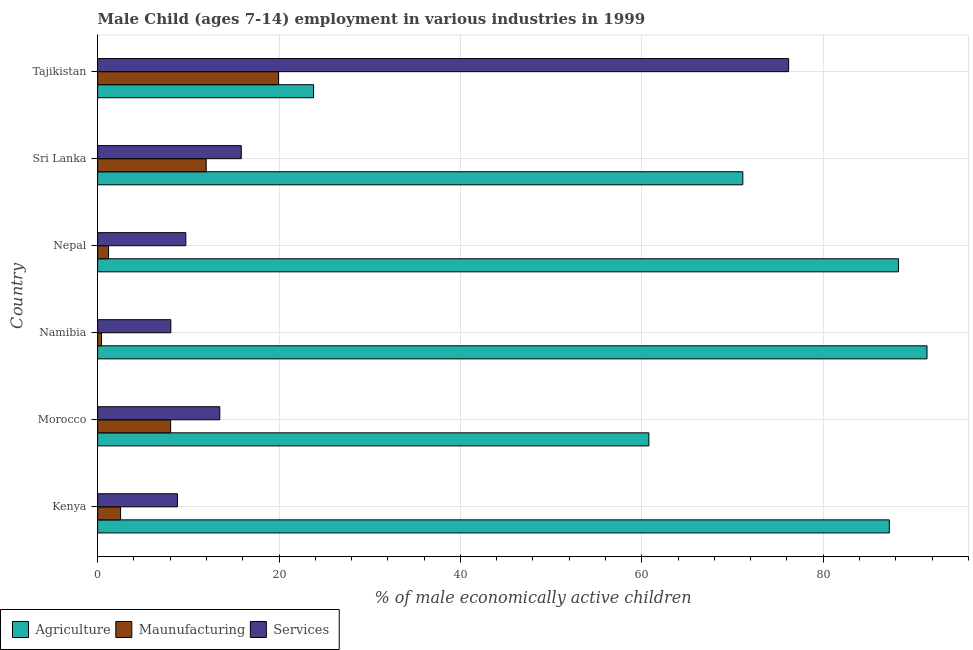Are the number of bars per tick equal to the number of legend labels?
Provide a succinct answer. Yes. Are the number of bars on each tick of the Y-axis equal?
Keep it short and to the point. Yes. What is the label of the 6th group of bars from the top?
Offer a very short reply. Kenya. In how many cases, is the number of bars for a given country not equal to the number of legend labels?
Your answer should be very brief. 0. What is the percentage of economically active children in services in Morocco?
Offer a very short reply. 13.47. Across all countries, what is the maximum percentage of economically active children in manufacturing?
Offer a very short reply. 19.94. Across all countries, what is the minimum percentage of economically active children in manufacturing?
Your answer should be very brief. 0.43. In which country was the percentage of economically active children in services maximum?
Your answer should be very brief. Tajikistan. In which country was the percentage of economically active children in manufacturing minimum?
Your response must be concise. Namibia. What is the total percentage of economically active children in agriculture in the graph?
Your answer should be compact. 422.77. What is the difference between the percentage of economically active children in agriculture in Nepal and that in Tajikistan?
Give a very brief answer. 64.49. What is the difference between the percentage of economically active children in services in Namibia and the percentage of economically active children in agriculture in Nepal?
Make the answer very short. -80.23. What is the average percentage of economically active children in agriculture per country?
Make the answer very short. 70.46. What is the difference between the percentage of economically active children in services and percentage of economically active children in agriculture in Namibia?
Provide a short and direct response. -83.38. What is the ratio of the percentage of economically active children in agriculture in Morocco to that in Tajikistan?
Give a very brief answer. 2.55. What is the difference between the highest and the second highest percentage of economically active children in services?
Offer a terse response. 60.35. What is the difference between the highest and the lowest percentage of economically active children in agriculture?
Offer a very short reply. 67.64. Is the sum of the percentage of economically active children in manufacturing in Morocco and Sri Lanka greater than the maximum percentage of economically active children in agriculture across all countries?
Ensure brevity in your answer.  No. What does the 1st bar from the top in Nepal represents?
Provide a short and direct response. Services. What does the 2nd bar from the bottom in Morocco represents?
Make the answer very short. Maunufacturing. How many countries are there in the graph?
Your answer should be very brief. 6. What is the difference between two consecutive major ticks on the X-axis?
Your answer should be very brief. 20. Are the values on the major ticks of X-axis written in scientific E-notation?
Give a very brief answer. No. Does the graph contain any zero values?
Give a very brief answer. No. How are the legend labels stacked?
Ensure brevity in your answer.  Horizontal. What is the title of the graph?
Your answer should be compact. Male Child (ages 7-14) employment in various industries in 1999. What is the label or title of the X-axis?
Your answer should be compact. % of male economically active children. What is the label or title of the Y-axis?
Your response must be concise. Country. What is the % of male economically active children of Agriculture in Kenya?
Give a very brief answer. 87.29. What is the % of male economically active children of Maunufacturing in Kenya?
Give a very brief answer. 2.53. What is the % of male economically active children in Services in Kenya?
Your answer should be very brief. 8.8. What is the % of male economically active children in Agriculture in Morocco?
Offer a very short reply. 60.78. What is the % of male economically active children in Maunufacturing in Morocco?
Your response must be concise. 8.05. What is the % of male economically active children in Services in Morocco?
Provide a succinct answer. 13.47. What is the % of male economically active children in Agriculture in Namibia?
Your response must be concise. 91.45. What is the % of male economically active children of Maunufacturing in Namibia?
Provide a short and direct response. 0.43. What is the % of male economically active children of Services in Namibia?
Your answer should be compact. 8.07. What is the % of male economically active children in Agriculture in Nepal?
Give a very brief answer. 88.3. What is the % of male economically active children of Maunufacturing in Nepal?
Give a very brief answer. 1.2. What is the % of male economically active children of Services in Nepal?
Offer a very short reply. 9.72. What is the % of male economically active children in Agriculture in Sri Lanka?
Give a very brief answer. 71.14. What is the % of male economically active children in Maunufacturing in Sri Lanka?
Keep it short and to the point. 11.97. What is the % of male economically active children in Services in Sri Lanka?
Ensure brevity in your answer.  15.84. What is the % of male economically active children of Agriculture in Tajikistan?
Ensure brevity in your answer.  23.81. What is the % of male economically active children in Maunufacturing in Tajikistan?
Keep it short and to the point. 19.94. What is the % of male economically active children of Services in Tajikistan?
Your response must be concise. 76.19. Across all countries, what is the maximum % of male economically active children of Agriculture?
Your response must be concise. 91.45. Across all countries, what is the maximum % of male economically active children in Maunufacturing?
Provide a succinct answer. 19.94. Across all countries, what is the maximum % of male economically active children of Services?
Ensure brevity in your answer.  76.19. Across all countries, what is the minimum % of male economically active children in Agriculture?
Give a very brief answer. 23.81. Across all countries, what is the minimum % of male economically active children of Maunufacturing?
Provide a succinct answer. 0.43. Across all countries, what is the minimum % of male economically active children of Services?
Give a very brief answer. 8.07. What is the total % of male economically active children of Agriculture in the graph?
Your response must be concise. 422.77. What is the total % of male economically active children in Maunufacturing in the graph?
Ensure brevity in your answer.  44.13. What is the total % of male economically active children in Services in the graph?
Provide a succinct answer. 132.09. What is the difference between the % of male economically active children of Agriculture in Kenya and that in Morocco?
Ensure brevity in your answer.  26.51. What is the difference between the % of male economically active children in Maunufacturing in Kenya and that in Morocco?
Your answer should be compact. -5.52. What is the difference between the % of male economically active children in Services in Kenya and that in Morocco?
Give a very brief answer. -4.67. What is the difference between the % of male economically active children of Agriculture in Kenya and that in Namibia?
Your answer should be very brief. -4.16. What is the difference between the % of male economically active children of Maunufacturing in Kenya and that in Namibia?
Provide a short and direct response. 2.1. What is the difference between the % of male economically active children of Services in Kenya and that in Namibia?
Keep it short and to the point. 0.73. What is the difference between the % of male economically active children in Agriculture in Kenya and that in Nepal?
Ensure brevity in your answer.  -1.01. What is the difference between the % of male economically active children of Maunufacturing in Kenya and that in Nepal?
Give a very brief answer. 1.33. What is the difference between the % of male economically active children of Services in Kenya and that in Nepal?
Ensure brevity in your answer.  -0.92. What is the difference between the % of male economically active children in Agriculture in Kenya and that in Sri Lanka?
Your response must be concise. 16.15. What is the difference between the % of male economically active children of Maunufacturing in Kenya and that in Sri Lanka?
Give a very brief answer. -9.44. What is the difference between the % of male economically active children of Services in Kenya and that in Sri Lanka?
Your answer should be compact. -7.04. What is the difference between the % of male economically active children in Agriculture in Kenya and that in Tajikistan?
Offer a terse response. 63.48. What is the difference between the % of male economically active children of Maunufacturing in Kenya and that in Tajikistan?
Ensure brevity in your answer.  -17.41. What is the difference between the % of male economically active children in Services in Kenya and that in Tajikistan?
Give a very brief answer. -67.39. What is the difference between the % of male economically active children of Agriculture in Morocco and that in Namibia?
Keep it short and to the point. -30.67. What is the difference between the % of male economically active children of Maunufacturing in Morocco and that in Namibia?
Make the answer very short. 7.62. What is the difference between the % of male economically active children of Agriculture in Morocco and that in Nepal?
Offer a very short reply. -27.52. What is the difference between the % of male economically active children in Maunufacturing in Morocco and that in Nepal?
Keep it short and to the point. 6.85. What is the difference between the % of male economically active children in Services in Morocco and that in Nepal?
Your answer should be very brief. 3.75. What is the difference between the % of male economically active children in Agriculture in Morocco and that in Sri Lanka?
Your answer should be very brief. -10.36. What is the difference between the % of male economically active children of Maunufacturing in Morocco and that in Sri Lanka?
Give a very brief answer. -3.92. What is the difference between the % of male economically active children of Services in Morocco and that in Sri Lanka?
Give a very brief answer. -2.37. What is the difference between the % of male economically active children of Agriculture in Morocco and that in Tajikistan?
Your response must be concise. 36.97. What is the difference between the % of male economically active children of Maunufacturing in Morocco and that in Tajikistan?
Give a very brief answer. -11.89. What is the difference between the % of male economically active children in Services in Morocco and that in Tajikistan?
Your answer should be compact. -62.72. What is the difference between the % of male economically active children of Agriculture in Namibia and that in Nepal?
Offer a very short reply. 3.15. What is the difference between the % of male economically active children in Maunufacturing in Namibia and that in Nepal?
Your response must be concise. -0.77. What is the difference between the % of male economically active children of Services in Namibia and that in Nepal?
Your answer should be compact. -1.65. What is the difference between the % of male economically active children of Agriculture in Namibia and that in Sri Lanka?
Offer a terse response. 20.31. What is the difference between the % of male economically active children of Maunufacturing in Namibia and that in Sri Lanka?
Make the answer very short. -11.54. What is the difference between the % of male economically active children of Services in Namibia and that in Sri Lanka?
Make the answer very short. -7.77. What is the difference between the % of male economically active children in Agriculture in Namibia and that in Tajikistan?
Your answer should be compact. 67.64. What is the difference between the % of male economically active children in Maunufacturing in Namibia and that in Tajikistan?
Ensure brevity in your answer.  -19.51. What is the difference between the % of male economically active children in Services in Namibia and that in Tajikistan?
Offer a very short reply. -68.12. What is the difference between the % of male economically active children in Agriculture in Nepal and that in Sri Lanka?
Your answer should be very brief. 17.16. What is the difference between the % of male economically active children of Maunufacturing in Nepal and that in Sri Lanka?
Give a very brief answer. -10.77. What is the difference between the % of male economically active children in Services in Nepal and that in Sri Lanka?
Give a very brief answer. -6.12. What is the difference between the % of male economically active children in Agriculture in Nepal and that in Tajikistan?
Give a very brief answer. 64.49. What is the difference between the % of male economically active children in Maunufacturing in Nepal and that in Tajikistan?
Your answer should be very brief. -18.74. What is the difference between the % of male economically active children of Services in Nepal and that in Tajikistan?
Give a very brief answer. -66.47. What is the difference between the % of male economically active children of Agriculture in Sri Lanka and that in Tajikistan?
Your response must be concise. 47.33. What is the difference between the % of male economically active children of Maunufacturing in Sri Lanka and that in Tajikistan?
Provide a succinct answer. -7.97. What is the difference between the % of male economically active children in Services in Sri Lanka and that in Tajikistan?
Your response must be concise. -60.35. What is the difference between the % of male economically active children in Agriculture in Kenya and the % of male economically active children in Maunufacturing in Morocco?
Provide a succinct answer. 79.24. What is the difference between the % of male economically active children of Agriculture in Kenya and the % of male economically active children of Services in Morocco?
Provide a short and direct response. 73.82. What is the difference between the % of male economically active children of Maunufacturing in Kenya and the % of male economically active children of Services in Morocco?
Offer a terse response. -10.94. What is the difference between the % of male economically active children in Agriculture in Kenya and the % of male economically active children in Maunufacturing in Namibia?
Offer a terse response. 86.86. What is the difference between the % of male economically active children in Agriculture in Kenya and the % of male economically active children in Services in Namibia?
Your answer should be very brief. 79.22. What is the difference between the % of male economically active children in Maunufacturing in Kenya and the % of male economically active children in Services in Namibia?
Offer a very short reply. -5.54. What is the difference between the % of male economically active children in Agriculture in Kenya and the % of male economically active children in Maunufacturing in Nepal?
Offer a very short reply. 86.09. What is the difference between the % of male economically active children in Agriculture in Kenya and the % of male economically active children in Services in Nepal?
Ensure brevity in your answer.  77.57. What is the difference between the % of male economically active children of Maunufacturing in Kenya and the % of male economically active children of Services in Nepal?
Keep it short and to the point. -7.19. What is the difference between the % of male economically active children of Agriculture in Kenya and the % of male economically active children of Maunufacturing in Sri Lanka?
Your answer should be compact. 75.32. What is the difference between the % of male economically active children in Agriculture in Kenya and the % of male economically active children in Services in Sri Lanka?
Give a very brief answer. 71.45. What is the difference between the % of male economically active children in Maunufacturing in Kenya and the % of male economically active children in Services in Sri Lanka?
Provide a succinct answer. -13.31. What is the difference between the % of male economically active children in Agriculture in Kenya and the % of male economically active children in Maunufacturing in Tajikistan?
Provide a succinct answer. 67.35. What is the difference between the % of male economically active children of Agriculture in Kenya and the % of male economically active children of Services in Tajikistan?
Ensure brevity in your answer.  11.1. What is the difference between the % of male economically active children in Maunufacturing in Kenya and the % of male economically active children in Services in Tajikistan?
Ensure brevity in your answer.  -73.66. What is the difference between the % of male economically active children of Agriculture in Morocco and the % of male economically active children of Maunufacturing in Namibia?
Offer a very short reply. 60.35. What is the difference between the % of male economically active children of Agriculture in Morocco and the % of male economically active children of Services in Namibia?
Make the answer very short. 52.71. What is the difference between the % of male economically active children of Maunufacturing in Morocco and the % of male economically active children of Services in Namibia?
Provide a succinct answer. -0.02. What is the difference between the % of male economically active children of Agriculture in Morocco and the % of male economically active children of Maunufacturing in Nepal?
Keep it short and to the point. 59.58. What is the difference between the % of male economically active children of Agriculture in Morocco and the % of male economically active children of Services in Nepal?
Keep it short and to the point. 51.06. What is the difference between the % of male economically active children in Maunufacturing in Morocco and the % of male economically active children in Services in Nepal?
Give a very brief answer. -1.67. What is the difference between the % of male economically active children in Agriculture in Morocco and the % of male economically active children in Maunufacturing in Sri Lanka?
Offer a very short reply. 48.81. What is the difference between the % of male economically active children of Agriculture in Morocco and the % of male economically active children of Services in Sri Lanka?
Provide a succinct answer. 44.94. What is the difference between the % of male economically active children of Maunufacturing in Morocco and the % of male economically active children of Services in Sri Lanka?
Offer a very short reply. -7.79. What is the difference between the % of male economically active children of Agriculture in Morocco and the % of male economically active children of Maunufacturing in Tajikistan?
Make the answer very short. 40.84. What is the difference between the % of male economically active children in Agriculture in Morocco and the % of male economically active children in Services in Tajikistan?
Provide a succinct answer. -15.41. What is the difference between the % of male economically active children of Maunufacturing in Morocco and the % of male economically active children of Services in Tajikistan?
Offer a terse response. -68.14. What is the difference between the % of male economically active children of Agriculture in Namibia and the % of male economically active children of Maunufacturing in Nepal?
Your answer should be compact. 90.25. What is the difference between the % of male economically active children of Agriculture in Namibia and the % of male economically active children of Services in Nepal?
Keep it short and to the point. 81.73. What is the difference between the % of male economically active children of Maunufacturing in Namibia and the % of male economically active children of Services in Nepal?
Give a very brief answer. -9.29. What is the difference between the % of male economically active children of Agriculture in Namibia and the % of male economically active children of Maunufacturing in Sri Lanka?
Provide a short and direct response. 79.48. What is the difference between the % of male economically active children in Agriculture in Namibia and the % of male economically active children in Services in Sri Lanka?
Provide a short and direct response. 75.61. What is the difference between the % of male economically active children of Maunufacturing in Namibia and the % of male economically active children of Services in Sri Lanka?
Your answer should be very brief. -15.41. What is the difference between the % of male economically active children of Agriculture in Namibia and the % of male economically active children of Maunufacturing in Tajikistan?
Make the answer very short. 71.51. What is the difference between the % of male economically active children in Agriculture in Namibia and the % of male economically active children in Services in Tajikistan?
Provide a succinct answer. 15.26. What is the difference between the % of male economically active children in Maunufacturing in Namibia and the % of male economically active children in Services in Tajikistan?
Keep it short and to the point. -75.76. What is the difference between the % of male economically active children of Agriculture in Nepal and the % of male economically active children of Maunufacturing in Sri Lanka?
Your response must be concise. 76.33. What is the difference between the % of male economically active children in Agriculture in Nepal and the % of male economically active children in Services in Sri Lanka?
Provide a succinct answer. 72.46. What is the difference between the % of male economically active children in Maunufacturing in Nepal and the % of male economically active children in Services in Sri Lanka?
Provide a succinct answer. -14.64. What is the difference between the % of male economically active children of Agriculture in Nepal and the % of male economically active children of Maunufacturing in Tajikistan?
Offer a very short reply. 68.36. What is the difference between the % of male economically active children in Agriculture in Nepal and the % of male economically active children in Services in Tajikistan?
Provide a short and direct response. 12.11. What is the difference between the % of male economically active children of Maunufacturing in Nepal and the % of male economically active children of Services in Tajikistan?
Keep it short and to the point. -74.99. What is the difference between the % of male economically active children of Agriculture in Sri Lanka and the % of male economically active children of Maunufacturing in Tajikistan?
Your answer should be very brief. 51.2. What is the difference between the % of male economically active children in Agriculture in Sri Lanka and the % of male economically active children in Services in Tajikistan?
Ensure brevity in your answer.  -5.05. What is the difference between the % of male economically active children in Maunufacturing in Sri Lanka and the % of male economically active children in Services in Tajikistan?
Ensure brevity in your answer.  -64.22. What is the average % of male economically active children in Agriculture per country?
Offer a very short reply. 70.46. What is the average % of male economically active children of Maunufacturing per country?
Offer a terse response. 7.35. What is the average % of male economically active children of Services per country?
Your answer should be very brief. 22.02. What is the difference between the % of male economically active children of Agriculture and % of male economically active children of Maunufacturing in Kenya?
Your answer should be very brief. 84.76. What is the difference between the % of male economically active children of Agriculture and % of male economically active children of Services in Kenya?
Give a very brief answer. 78.49. What is the difference between the % of male economically active children of Maunufacturing and % of male economically active children of Services in Kenya?
Your answer should be very brief. -6.27. What is the difference between the % of male economically active children in Agriculture and % of male economically active children in Maunufacturing in Morocco?
Make the answer very short. 52.73. What is the difference between the % of male economically active children in Agriculture and % of male economically active children in Services in Morocco?
Your answer should be compact. 47.31. What is the difference between the % of male economically active children in Maunufacturing and % of male economically active children in Services in Morocco?
Make the answer very short. -5.42. What is the difference between the % of male economically active children of Agriculture and % of male economically active children of Maunufacturing in Namibia?
Ensure brevity in your answer.  91.02. What is the difference between the % of male economically active children of Agriculture and % of male economically active children of Services in Namibia?
Offer a very short reply. 83.38. What is the difference between the % of male economically active children in Maunufacturing and % of male economically active children in Services in Namibia?
Give a very brief answer. -7.64. What is the difference between the % of male economically active children in Agriculture and % of male economically active children in Maunufacturing in Nepal?
Keep it short and to the point. 87.1. What is the difference between the % of male economically active children of Agriculture and % of male economically active children of Services in Nepal?
Provide a short and direct response. 78.58. What is the difference between the % of male economically active children of Maunufacturing and % of male economically active children of Services in Nepal?
Ensure brevity in your answer.  -8.52. What is the difference between the % of male economically active children in Agriculture and % of male economically active children in Maunufacturing in Sri Lanka?
Keep it short and to the point. 59.17. What is the difference between the % of male economically active children in Agriculture and % of male economically active children in Services in Sri Lanka?
Ensure brevity in your answer.  55.3. What is the difference between the % of male economically active children of Maunufacturing and % of male economically active children of Services in Sri Lanka?
Your answer should be compact. -3.87. What is the difference between the % of male economically active children in Agriculture and % of male economically active children in Maunufacturing in Tajikistan?
Give a very brief answer. 3.87. What is the difference between the % of male economically active children in Agriculture and % of male economically active children in Services in Tajikistan?
Your answer should be very brief. -52.38. What is the difference between the % of male economically active children in Maunufacturing and % of male economically active children in Services in Tajikistan?
Your answer should be compact. -56.25. What is the ratio of the % of male economically active children in Agriculture in Kenya to that in Morocco?
Provide a short and direct response. 1.44. What is the ratio of the % of male economically active children in Maunufacturing in Kenya to that in Morocco?
Offer a very short reply. 0.31. What is the ratio of the % of male economically active children of Services in Kenya to that in Morocco?
Ensure brevity in your answer.  0.65. What is the ratio of the % of male economically active children of Agriculture in Kenya to that in Namibia?
Make the answer very short. 0.95. What is the ratio of the % of male economically active children of Maunufacturing in Kenya to that in Namibia?
Offer a very short reply. 5.88. What is the ratio of the % of male economically active children in Services in Kenya to that in Namibia?
Give a very brief answer. 1.09. What is the ratio of the % of male economically active children of Maunufacturing in Kenya to that in Nepal?
Make the answer very short. 2.1. What is the ratio of the % of male economically active children of Services in Kenya to that in Nepal?
Make the answer very short. 0.91. What is the ratio of the % of male economically active children in Agriculture in Kenya to that in Sri Lanka?
Keep it short and to the point. 1.23. What is the ratio of the % of male economically active children of Maunufacturing in Kenya to that in Sri Lanka?
Offer a terse response. 0.21. What is the ratio of the % of male economically active children in Services in Kenya to that in Sri Lanka?
Make the answer very short. 0.56. What is the ratio of the % of male economically active children of Agriculture in Kenya to that in Tajikistan?
Offer a terse response. 3.67. What is the ratio of the % of male economically active children of Maunufacturing in Kenya to that in Tajikistan?
Give a very brief answer. 0.13. What is the ratio of the % of male economically active children of Services in Kenya to that in Tajikistan?
Ensure brevity in your answer.  0.12. What is the ratio of the % of male economically active children in Agriculture in Morocco to that in Namibia?
Ensure brevity in your answer.  0.66. What is the ratio of the % of male economically active children of Maunufacturing in Morocco to that in Namibia?
Ensure brevity in your answer.  18.72. What is the ratio of the % of male economically active children of Services in Morocco to that in Namibia?
Make the answer very short. 1.67. What is the ratio of the % of male economically active children of Agriculture in Morocco to that in Nepal?
Keep it short and to the point. 0.69. What is the ratio of the % of male economically active children of Maunufacturing in Morocco to that in Nepal?
Provide a succinct answer. 6.69. What is the ratio of the % of male economically active children of Services in Morocco to that in Nepal?
Your answer should be very brief. 1.39. What is the ratio of the % of male economically active children of Agriculture in Morocco to that in Sri Lanka?
Provide a short and direct response. 0.85. What is the ratio of the % of male economically active children of Maunufacturing in Morocco to that in Sri Lanka?
Offer a very short reply. 0.67. What is the ratio of the % of male economically active children of Services in Morocco to that in Sri Lanka?
Ensure brevity in your answer.  0.85. What is the ratio of the % of male economically active children of Agriculture in Morocco to that in Tajikistan?
Give a very brief answer. 2.55. What is the ratio of the % of male economically active children in Maunufacturing in Morocco to that in Tajikistan?
Provide a succinct answer. 0.4. What is the ratio of the % of male economically active children in Services in Morocco to that in Tajikistan?
Provide a short and direct response. 0.18. What is the ratio of the % of male economically active children of Agriculture in Namibia to that in Nepal?
Provide a succinct answer. 1.04. What is the ratio of the % of male economically active children of Maunufacturing in Namibia to that in Nepal?
Provide a succinct answer. 0.36. What is the ratio of the % of male economically active children in Services in Namibia to that in Nepal?
Your response must be concise. 0.83. What is the ratio of the % of male economically active children in Agriculture in Namibia to that in Sri Lanka?
Keep it short and to the point. 1.29. What is the ratio of the % of male economically active children of Maunufacturing in Namibia to that in Sri Lanka?
Make the answer very short. 0.04. What is the ratio of the % of male economically active children in Services in Namibia to that in Sri Lanka?
Ensure brevity in your answer.  0.51. What is the ratio of the % of male economically active children in Agriculture in Namibia to that in Tajikistan?
Provide a succinct answer. 3.84. What is the ratio of the % of male economically active children of Maunufacturing in Namibia to that in Tajikistan?
Your answer should be very brief. 0.02. What is the ratio of the % of male economically active children of Services in Namibia to that in Tajikistan?
Your answer should be very brief. 0.11. What is the ratio of the % of male economically active children of Agriculture in Nepal to that in Sri Lanka?
Make the answer very short. 1.24. What is the ratio of the % of male economically active children in Maunufacturing in Nepal to that in Sri Lanka?
Your response must be concise. 0.1. What is the ratio of the % of male economically active children of Services in Nepal to that in Sri Lanka?
Make the answer very short. 0.61. What is the ratio of the % of male economically active children of Agriculture in Nepal to that in Tajikistan?
Your answer should be very brief. 3.71. What is the ratio of the % of male economically active children in Maunufacturing in Nepal to that in Tajikistan?
Offer a very short reply. 0.06. What is the ratio of the % of male economically active children of Services in Nepal to that in Tajikistan?
Keep it short and to the point. 0.13. What is the ratio of the % of male economically active children in Agriculture in Sri Lanka to that in Tajikistan?
Give a very brief answer. 2.99. What is the ratio of the % of male economically active children of Maunufacturing in Sri Lanka to that in Tajikistan?
Provide a short and direct response. 0.6. What is the ratio of the % of male economically active children of Services in Sri Lanka to that in Tajikistan?
Your answer should be compact. 0.21. What is the difference between the highest and the second highest % of male economically active children of Agriculture?
Keep it short and to the point. 3.15. What is the difference between the highest and the second highest % of male economically active children in Maunufacturing?
Offer a very short reply. 7.97. What is the difference between the highest and the second highest % of male economically active children of Services?
Provide a short and direct response. 60.35. What is the difference between the highest and the lowest % of male economically active children in Agriculture?
Your answer should be compact. 67.64. What is the difference between the highest and the lowest % of male economically active children of Maunufacturing?
Ensure brevity in your answer.  19.51. What is the difference between the highest and the lowest % of male economically active children of Services?
Make the answer very short. 68.12. 